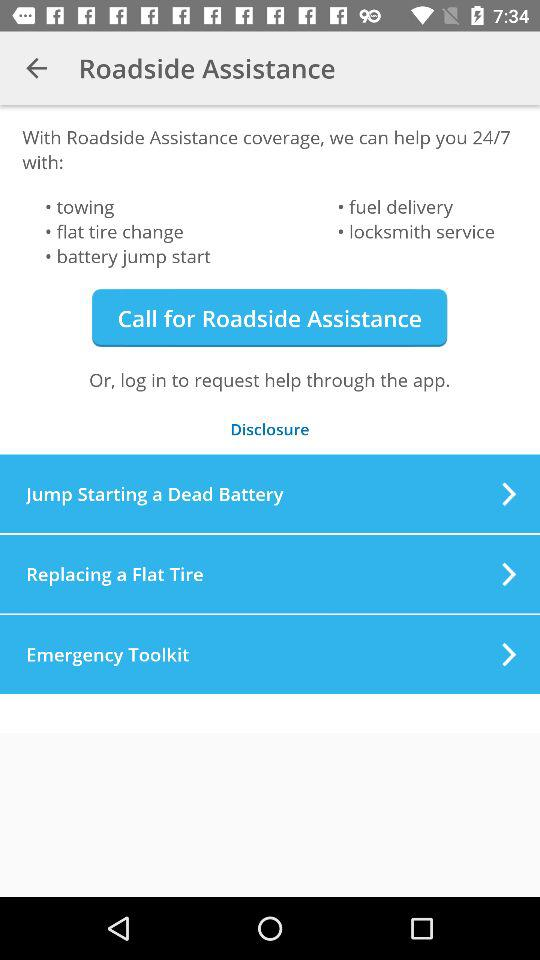When is roadside assistance available for help? Roadside assistance is available for help 24/7. 